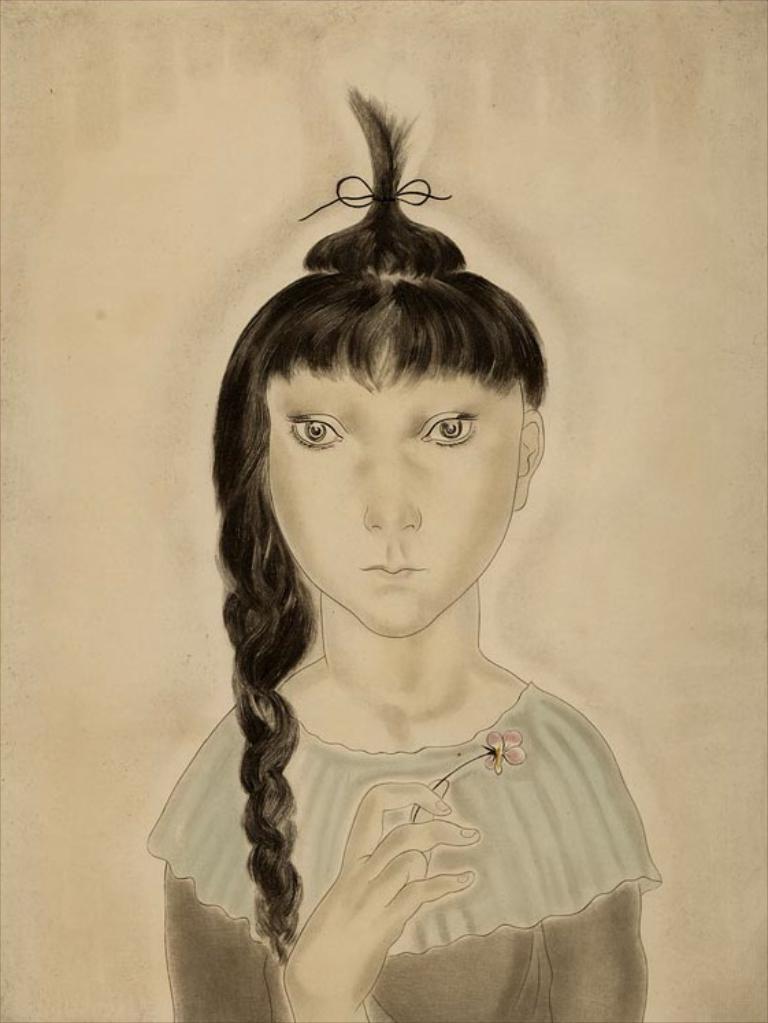Could you give a brief overview of what you see in this image? In this image I can see a drawing of a person holding a flower in hand. I can see the brown colored background. 